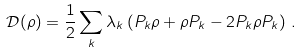<formula> <loc_0><loc_0><loc_500><loc_500>\mathcal { D } ( \rho ) = \frac { 1 } { 2 } \sum _ { k } \lambda _ { k } \left ( P _ { k } \rho + \rho P _ { k } - 2 P _ { k } \rho P _ { k } \right ) \, .</formula> 